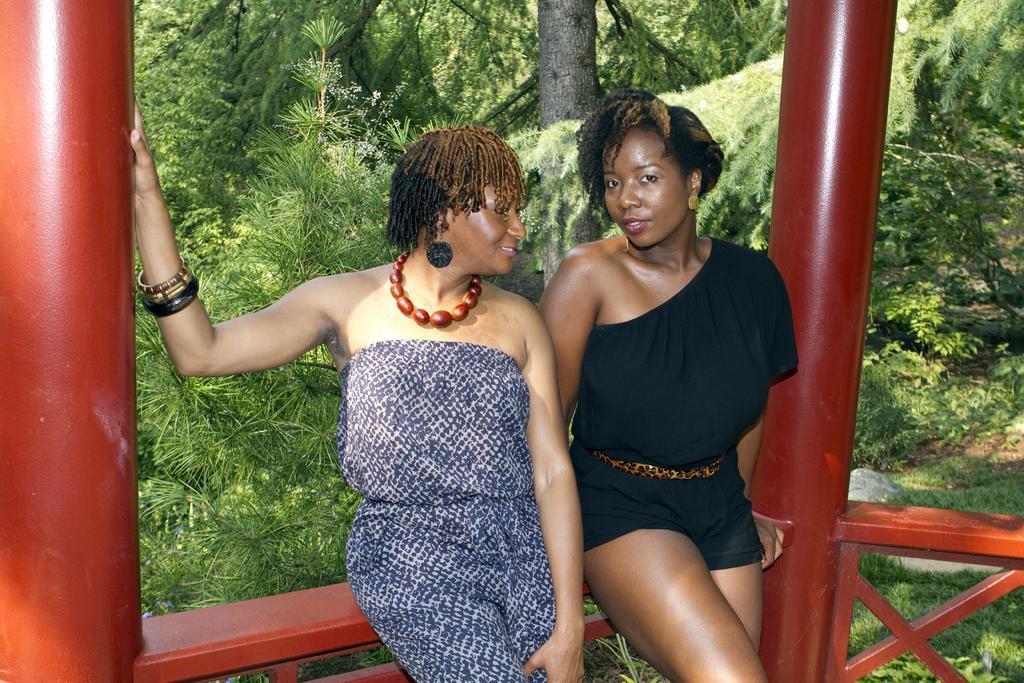Please provide a concise description of this image. In this image we can see two women sitting on the fence. We can also see some poles. On the backside we can see the bark of a tree, some plants and a group of trees. 